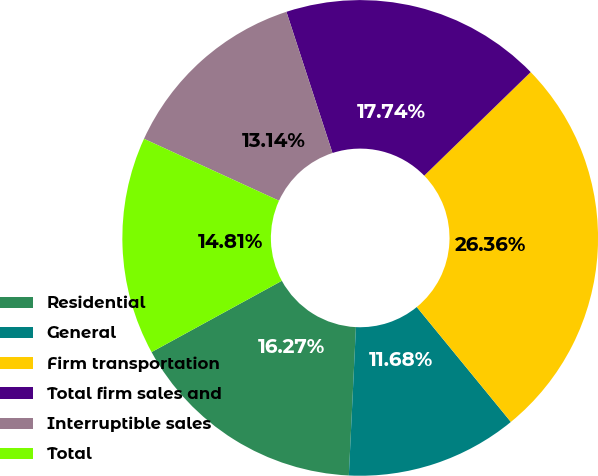Convert chart to OTSL. <chart><loc_0><loc_0><loc_500><loc_500><pie_chart><fcel>Residential<fcel>General<fcel>Firm transportation<fcel>Total firm sales and<fcel>Interruptible sales<fcel>Total<nl><fcel>16.27%<fcel>11.68%<fcel>26.36%<fcel>17.74%<fcel>13.14%<fcel>14.81%<nl></chart> 